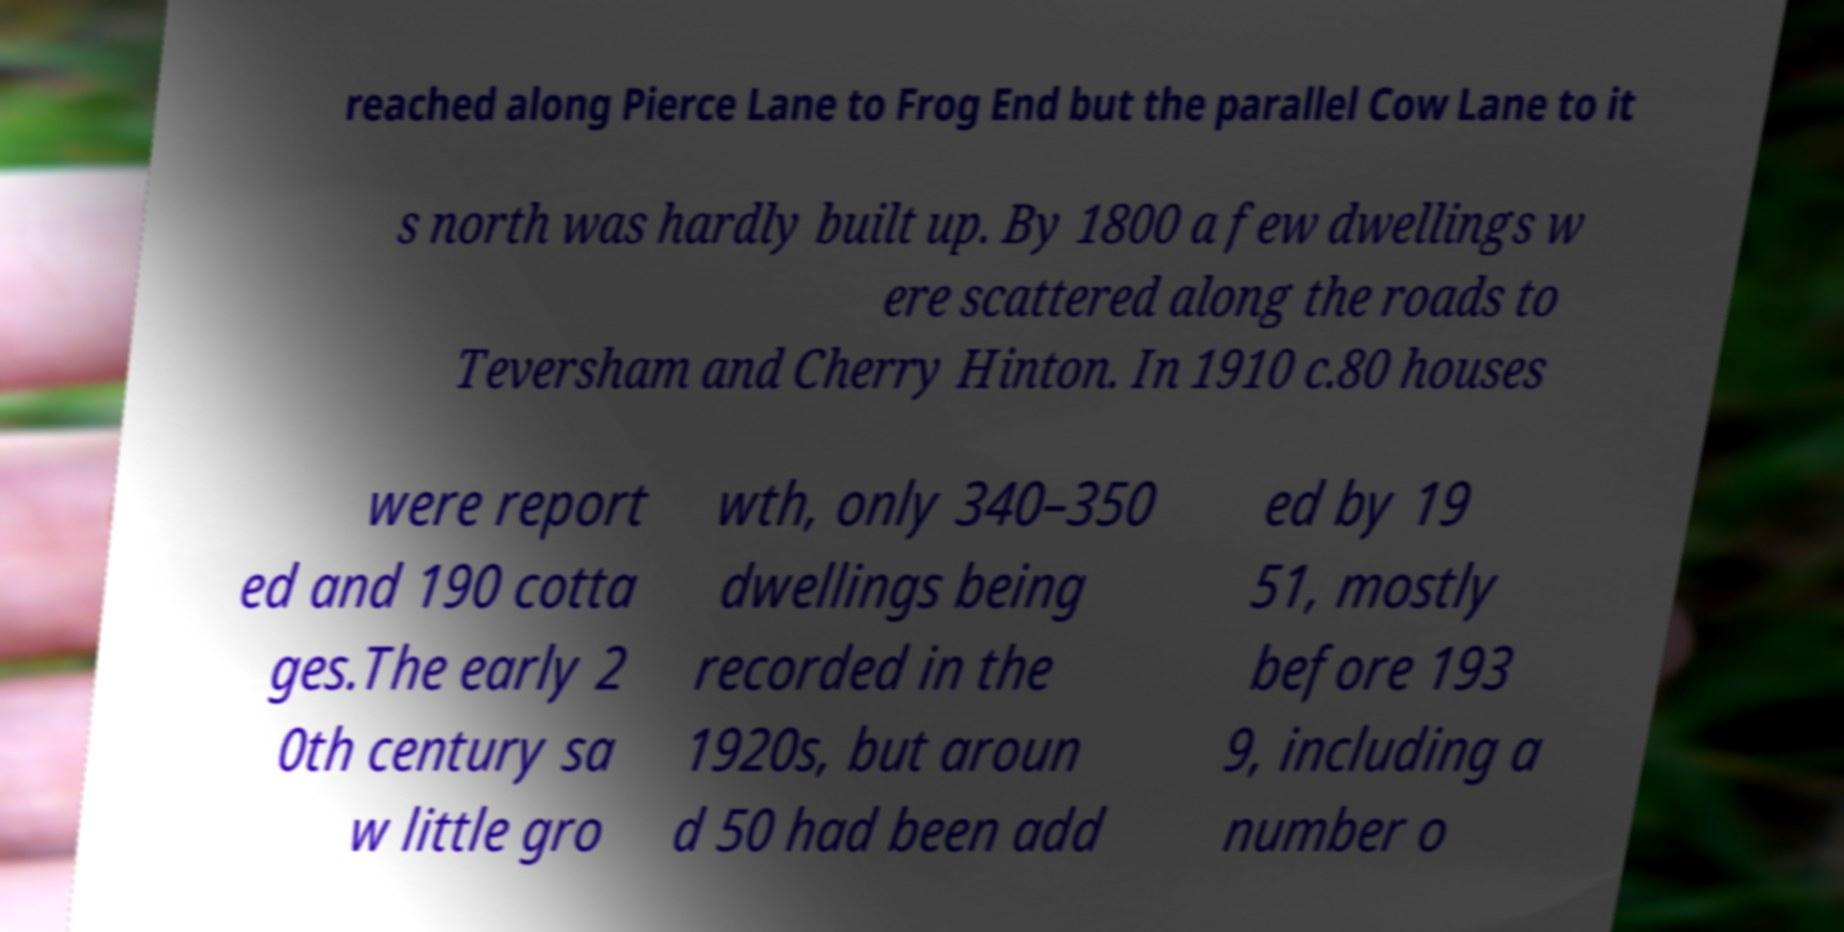Please identify and transcribe the text found in this image. reached along Pierce Lane to Frog End but the parallel Cow Lane to it s north was hardly built up. By 1800 a few dwellings w ere scattered along the roads to Teversham and Cherry Hinton. In 1910 c.80 houses were report ed and 190 cotta ges.The early 2 0th century sa w little gro wth, only 340–350 dwellings being recorded in the 1920s, but aroun d 50 had been add ed by 19 51, mostly before 193 9, including a number o 